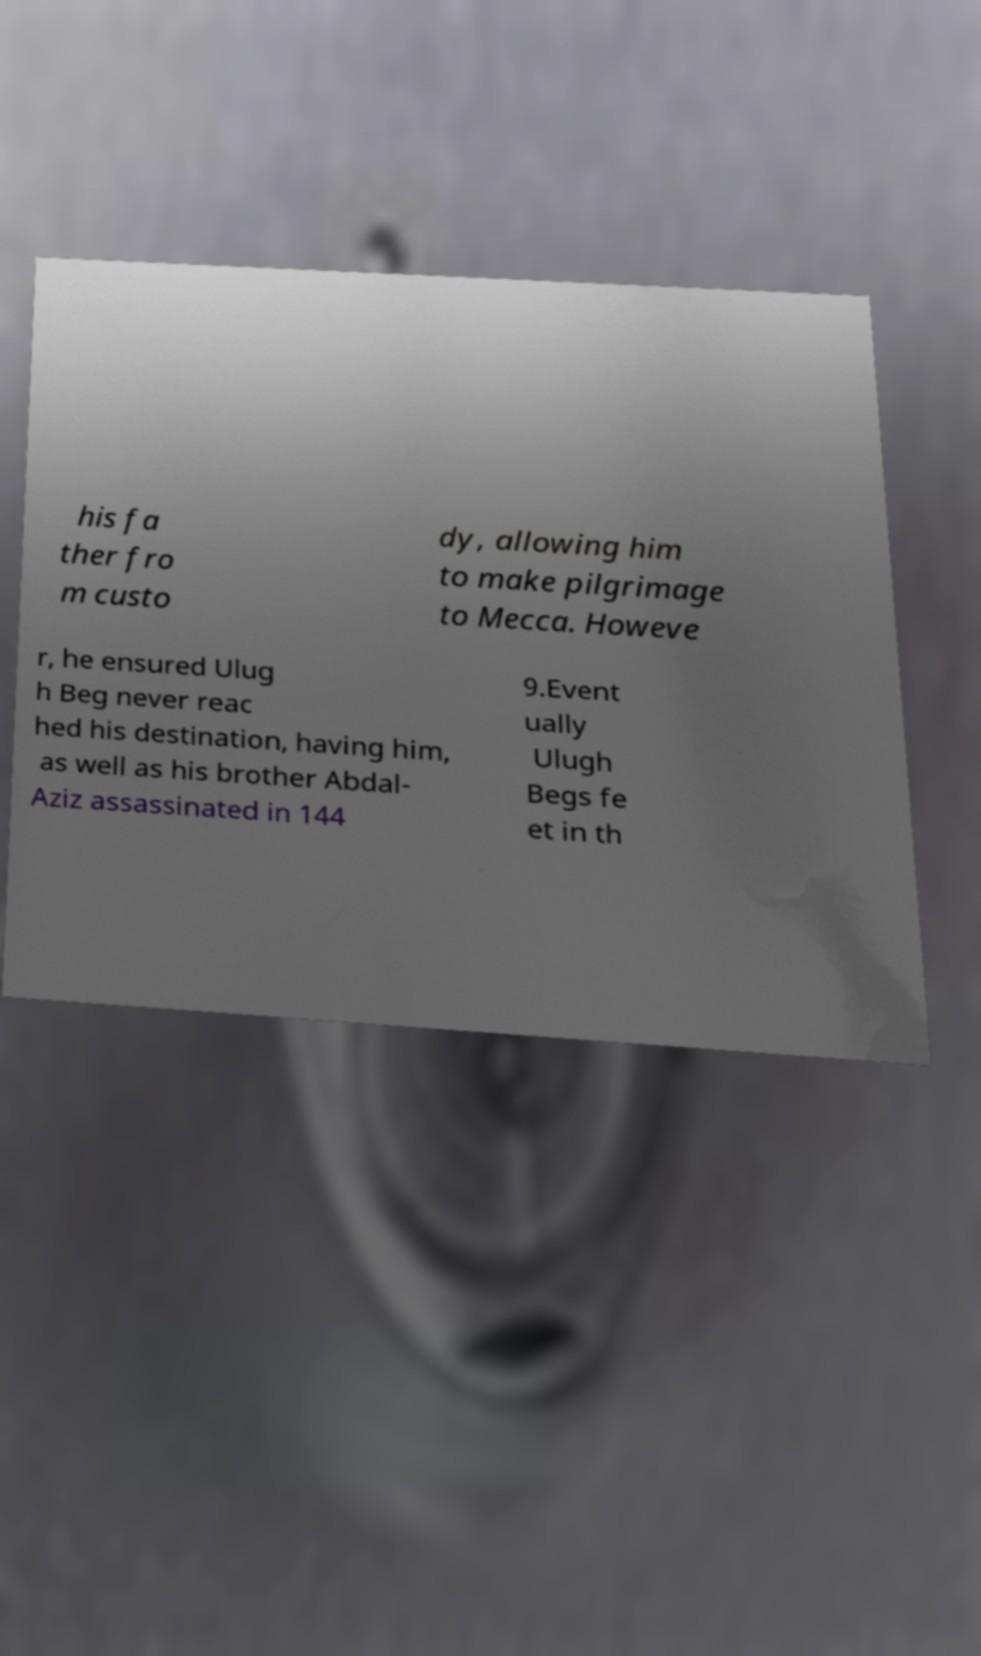Could you assist in decoding the text presented in this image and type it out clearly? his fa ther fro m custo dy, allowing him to make pilgrimage to Mecca. Howeve r, he ensured Ulug h Beg never reac hed his destination, having him, as well as his brother Abdal- Aziz assassinated in 144 9.Event ually Ulugh Begs fe et in th 